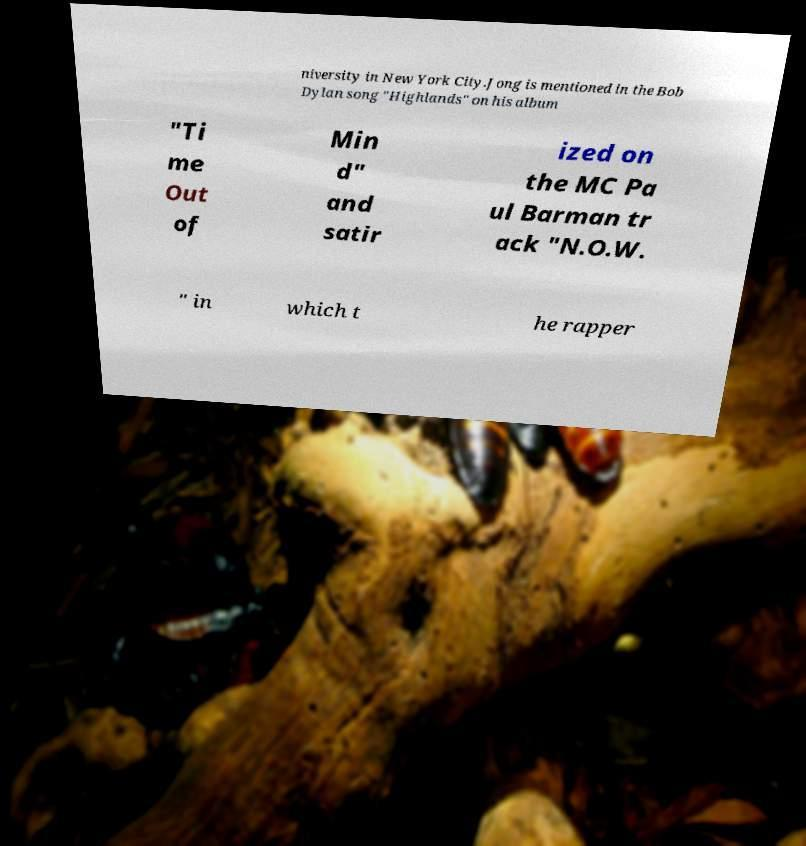There's text embedded in this image that I need extracted. Can you transcribe it verbatim? niversity in New York City.Jong is mentioned in the Bob Dylan song "Highlands" on his album "Ti me Out of Min d" and satir ized on the MC Pa ul Barman tr ack "N.O.W. " in which t he rapper 